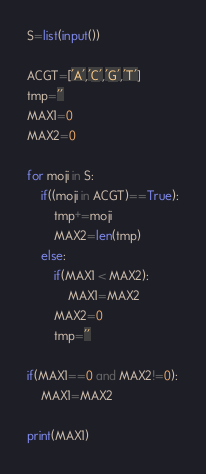<code> <loc_0><loc_0><loc_500><loc_500><_Python_>S=list(input())

ACGT=['A','C','G','T']
tmp=''
MAX1=0
MAX2=0

for moji in S:
    if((moji in ACGT)==True):
        tmp+=moji
        MAX2=len(tmp)
    else:
        if(MAX1 < MAX2):
            MAX1=MAX2
        MAX2=0
        tmp=''

if(MAX1==0 and MAX2!=0):
    MAX1=MAX2

print(MAX1)
</code> 